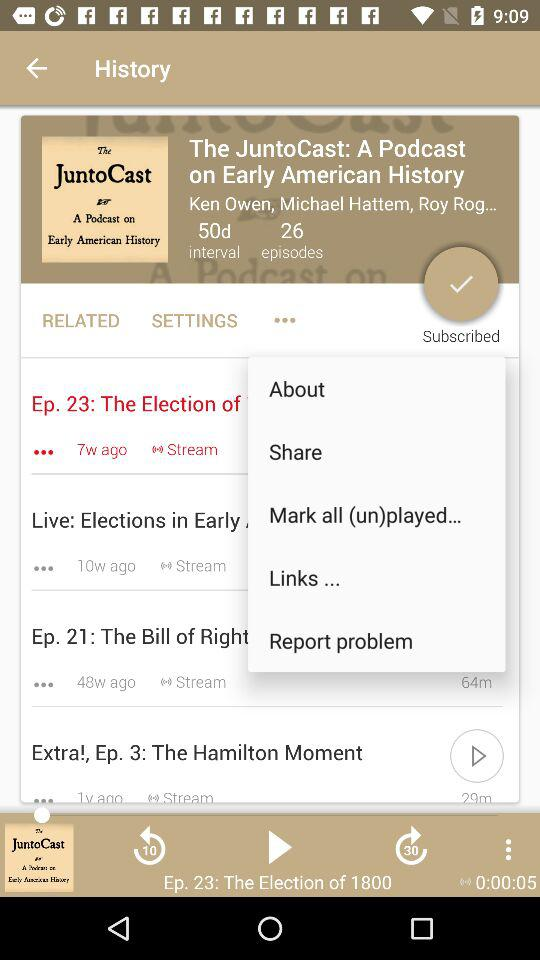Which audio was last played? The last played audio was "Ep. 23: The Election of 1800". 